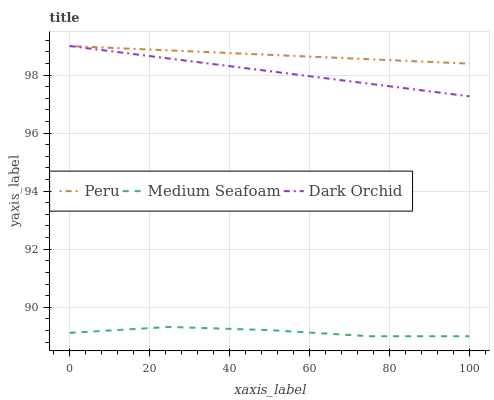Does Peru have the minimum area under the curve?
Answer yes or no. No. Does Medium Seafoam have the maximum area under the curve?
Answer yes or no. No. Is Medium Seafoam the smoothest?
Answer yes or no. No. Is Peru the roughest?
Answer yes or no. No. Does Peru have the lowest value?
Answer yes or no. No. Does Medium Seafoam have the highest value?
Answer yes or no. No. Is Medium Seafoam less than Peru?
Answer yes or no. Yes. Is Peru greater than Medium Seafoam?
Answer yes or no. Yes. Does Medium Seafoam intersect Peru?
Answer yes or no. No. 